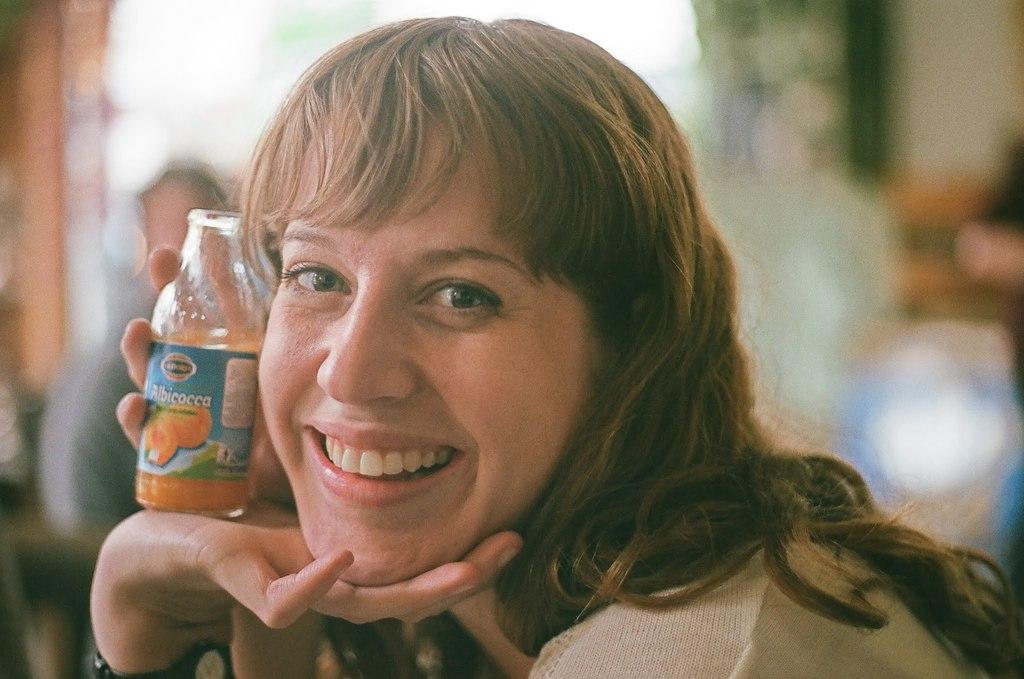Who is the main subject in the image? There is a lady in the image. What is the lady wearing on her wrist? The lady is wearing a watch. What object is the lady holding in the image? The lady is holding a bottle. What expression does the lady have on her face? The lady is smiling. Can you describe the background of the image? The background of the image is blurred. How many ducks can be seen at the edge of the wave in the image? There are no ducks or waves present in the image; it features a lady with a watch, a bottle, and a blurred background. 